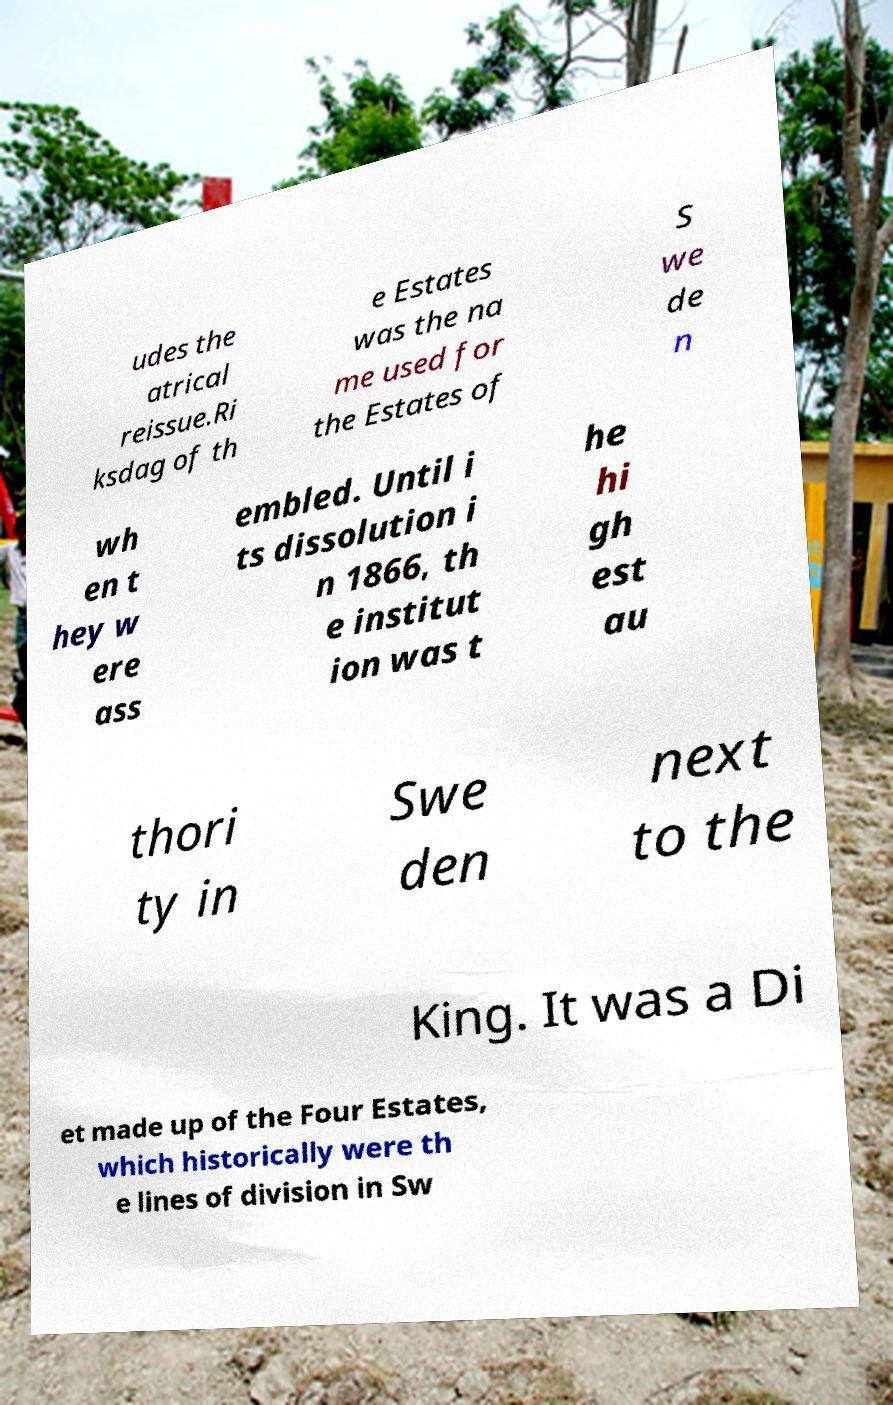There's text embedded in this image that I need extracted. Can you transcribe it verbatim? udes the atrical reissue.Ri ksdag of th e Estates was the na me used for the Estates of S we de n wh en t hey w ere ass embled. Until i ts dissolution i n 1866, th e institut ion was t he hi gh est au thori ty in Swe den next to the King. It was a Di et made up of the Four Estates, which historically were th e lines of division in Sw 